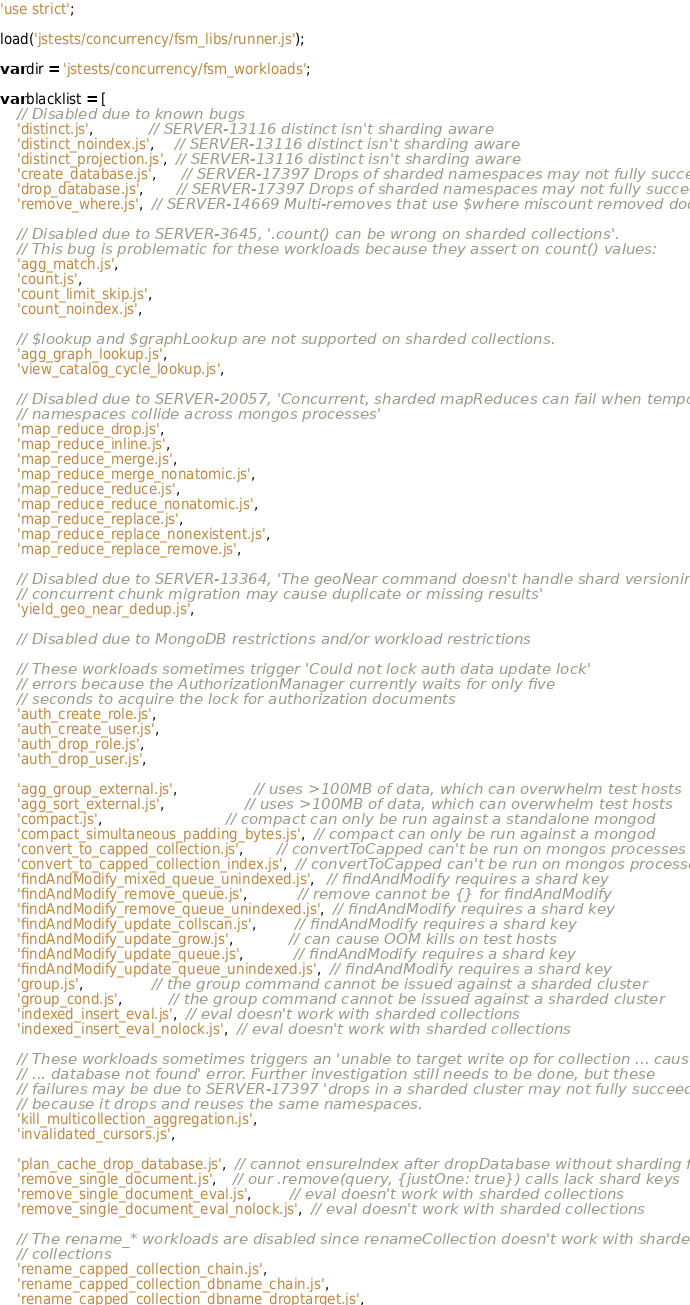<code> <loc_0><loc_0><loc_500><loc_500><_JavaScript_>'use strict';

load('jstests/concurrency/fsm_libs/runner.js');

var dir = 'jstests/concurrency/fsm_workloads';

var blacklist = [
    // Disabled due to known bugs
    'distinct.js',             // SERVER-13116 distinct isn't sharding aware
    'distinct_noindex.js',     // SERVER-13116 distinct isn't sharding aware
    'distinct_projection.js',  // SERVER-13116 distinct isn't sharding aware
    'create_database.js',      // SERVER-17397 Drops of sharded namespaces may not fully succeed
    'drop_database.js',        // SERVER-17397 Drops of sharded namespaces may not fully succeed
    'remove_where.js',  // SERVER-14669 Multi-removes that use $where miscount removed documents

    // Disabled due to SERVER-3645, '.count() can be wrong on sharded collections'.
    // This bug is problematic for these workloads because they assert on count() values:
    'agg_match.js',
    'count.js',
    'count_limit_skip.js',
    'count_noindex.js',

    // $lookup and $graphLookup are not supported on sharded collections.
    'agg_graph_lookup.js',
    'view_catalog_cycle_lookup.js',

    // Disabled due to SERVER-20057, 'Concurrent, sharded mapReduces can fail when temporary
    // namespaces collide across mongos processes'
    'map_reduce_drop.js',
    'map_reduce_inline.js',
    'map_reduce_merge.js',
    'map_reduce_merge_nonatomic.js',
    'map_reduce_reduce.js',
    'map_reduce_reduce_nonatomic.js',
    'map_reduce_replace.js',
    'map_reduce_replace_nonexistent.js',
    'map_reduce_replace_remove.js',

    // Disabled due to SERVER-13364, 'The geoNear command doesn't handle shard versioning, so a
    // concurrent chunk migration may cause duplicate or missing results'
    'yield_geo_near_dedup.js',

    // Disabled due to MongoDB restrictions and/or workload restrictions

    // These workloads sometimes trigger 'Could not lock auth data update lock'
    // errors because the AuthorizationManager currently waits for only five
    // seconds to acquire the lock for authorization documents
    'auth_create_role.js',
    'auth_create_user.js',
    'auth_drop_role.js',
    'auth_drop_user.js',

    'agg_group_external.js',                  // uses >100MB of data, which can overwhelm test hosts
    'agg_sort_external.js',                   // uses >100MB of data, which can overwhelm test hosts
    'compact.js',                             // compact can only be run against a standalone mongod
    'compact_simultaneous_padding_bytes.js',  // compact can only be run against a mongod
    'convert_to_capped_collection.js',        // convertToCapped can't be run on mongos processes
    'convert_to_capped_collection_index.js',  // convertToCapped can't be run on mongos processes
    'findAndModify_mixed_queue_unindexed.js',   // findAndModify requires a shard key
    'findAndModify_remove_queue.js',            // remove cannot be {} for findAndModify
    'findAndModify_remove_queue_unindexed.js',  // findAndModify requires a shard key
    'findAndModify_update_collscan.js',         // findAndModify requires a shard key
    'findAndModify_update_grow.js',             // can cause OOM kills on test hosts
    'findAndModify_update_queue.js',            // findAndModify requires a shard key
    'findAndModify_update_queue_unindexed.js',  // findAndModify requires a shard key
    'group.js',                // the group command cannot be issued against a sharded cluster
    'group_cond.js',           // the group command cannot be issued against a sharded cluster
    'indexed_insert_eval.js',  // eval doesn't work with sharded collections
    'indexed_insert_eval_nolock.js',  // eval doesn't work with sharded collections

    // These workloads sometimes triggers an 'unable to target write op for collection ... caused by
    // ... database not found' error. Further investigation still needs to be done, but these
    // failures may be due to SERVER-17397 'drops in a sharded cluster may not fully succeed'
    // because it drops and reuses the same namespaces.
    'kill_multicollection_aggregation.js',
    'invalidated_cursors.js',

    'plan_cache_drop_database.js',  // cannot ensureIndex after dropDatabase without sharding first
    'remove_single_document.js',    // our .remove(query, {justOne: true}) calls lack shard keys
    'remove_single_document_eval.js',         // eval doesn't work with sharded collections
    'remove_single_document_eval_nolock.js',  // eval doesn't work with sharded collections

    // The rename_* workloads are disabled since renameCollection doesn't work with sharded
    // collections
    'rename_capped_collection_chain.js',
    'rename_capped_collection_dbname_chain.js',
    'rename_capped_collection_dbname_droptarget.js',</code> 